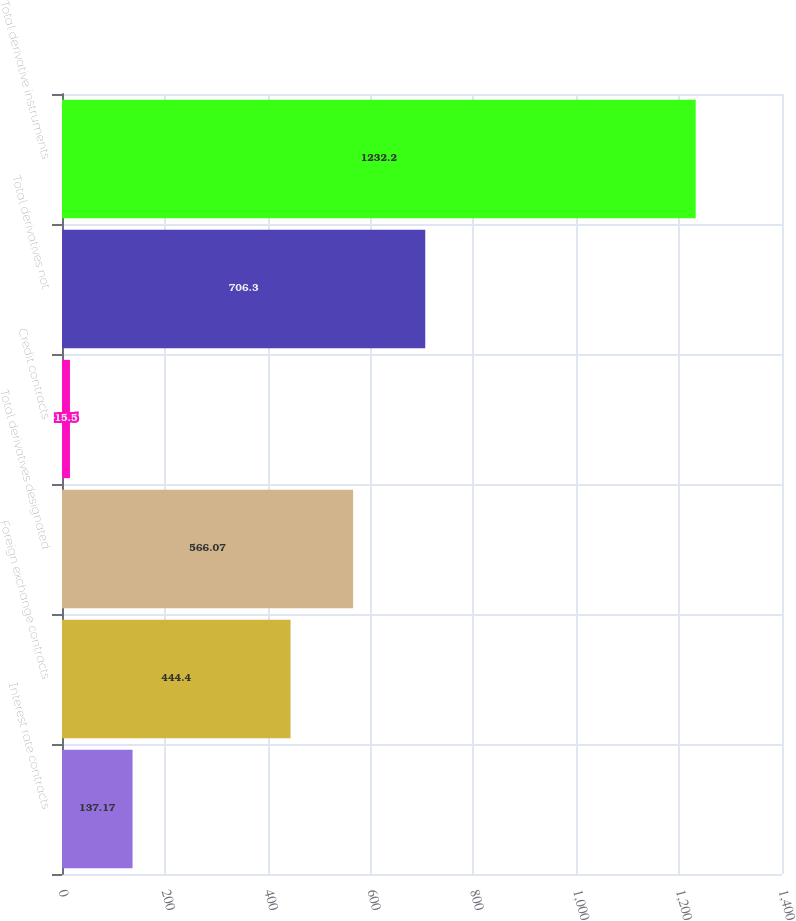Convert chart to OTSL. <chart><loc_0><loc_0><loc_500><loc_500><bar_chart><fcel>Interest rate contracts<fcel>Foreign exchange contracts<fcel>Total derivatives designated<fcel>Credit contracts<fcel>Total derivatives not<fcel>Total derivative instruments<nl><fcel>137.17<fcel>444.4<fcel>566.07<fcel>15.5<fcel>706.3<fcel>1232.2<nl></chart> 